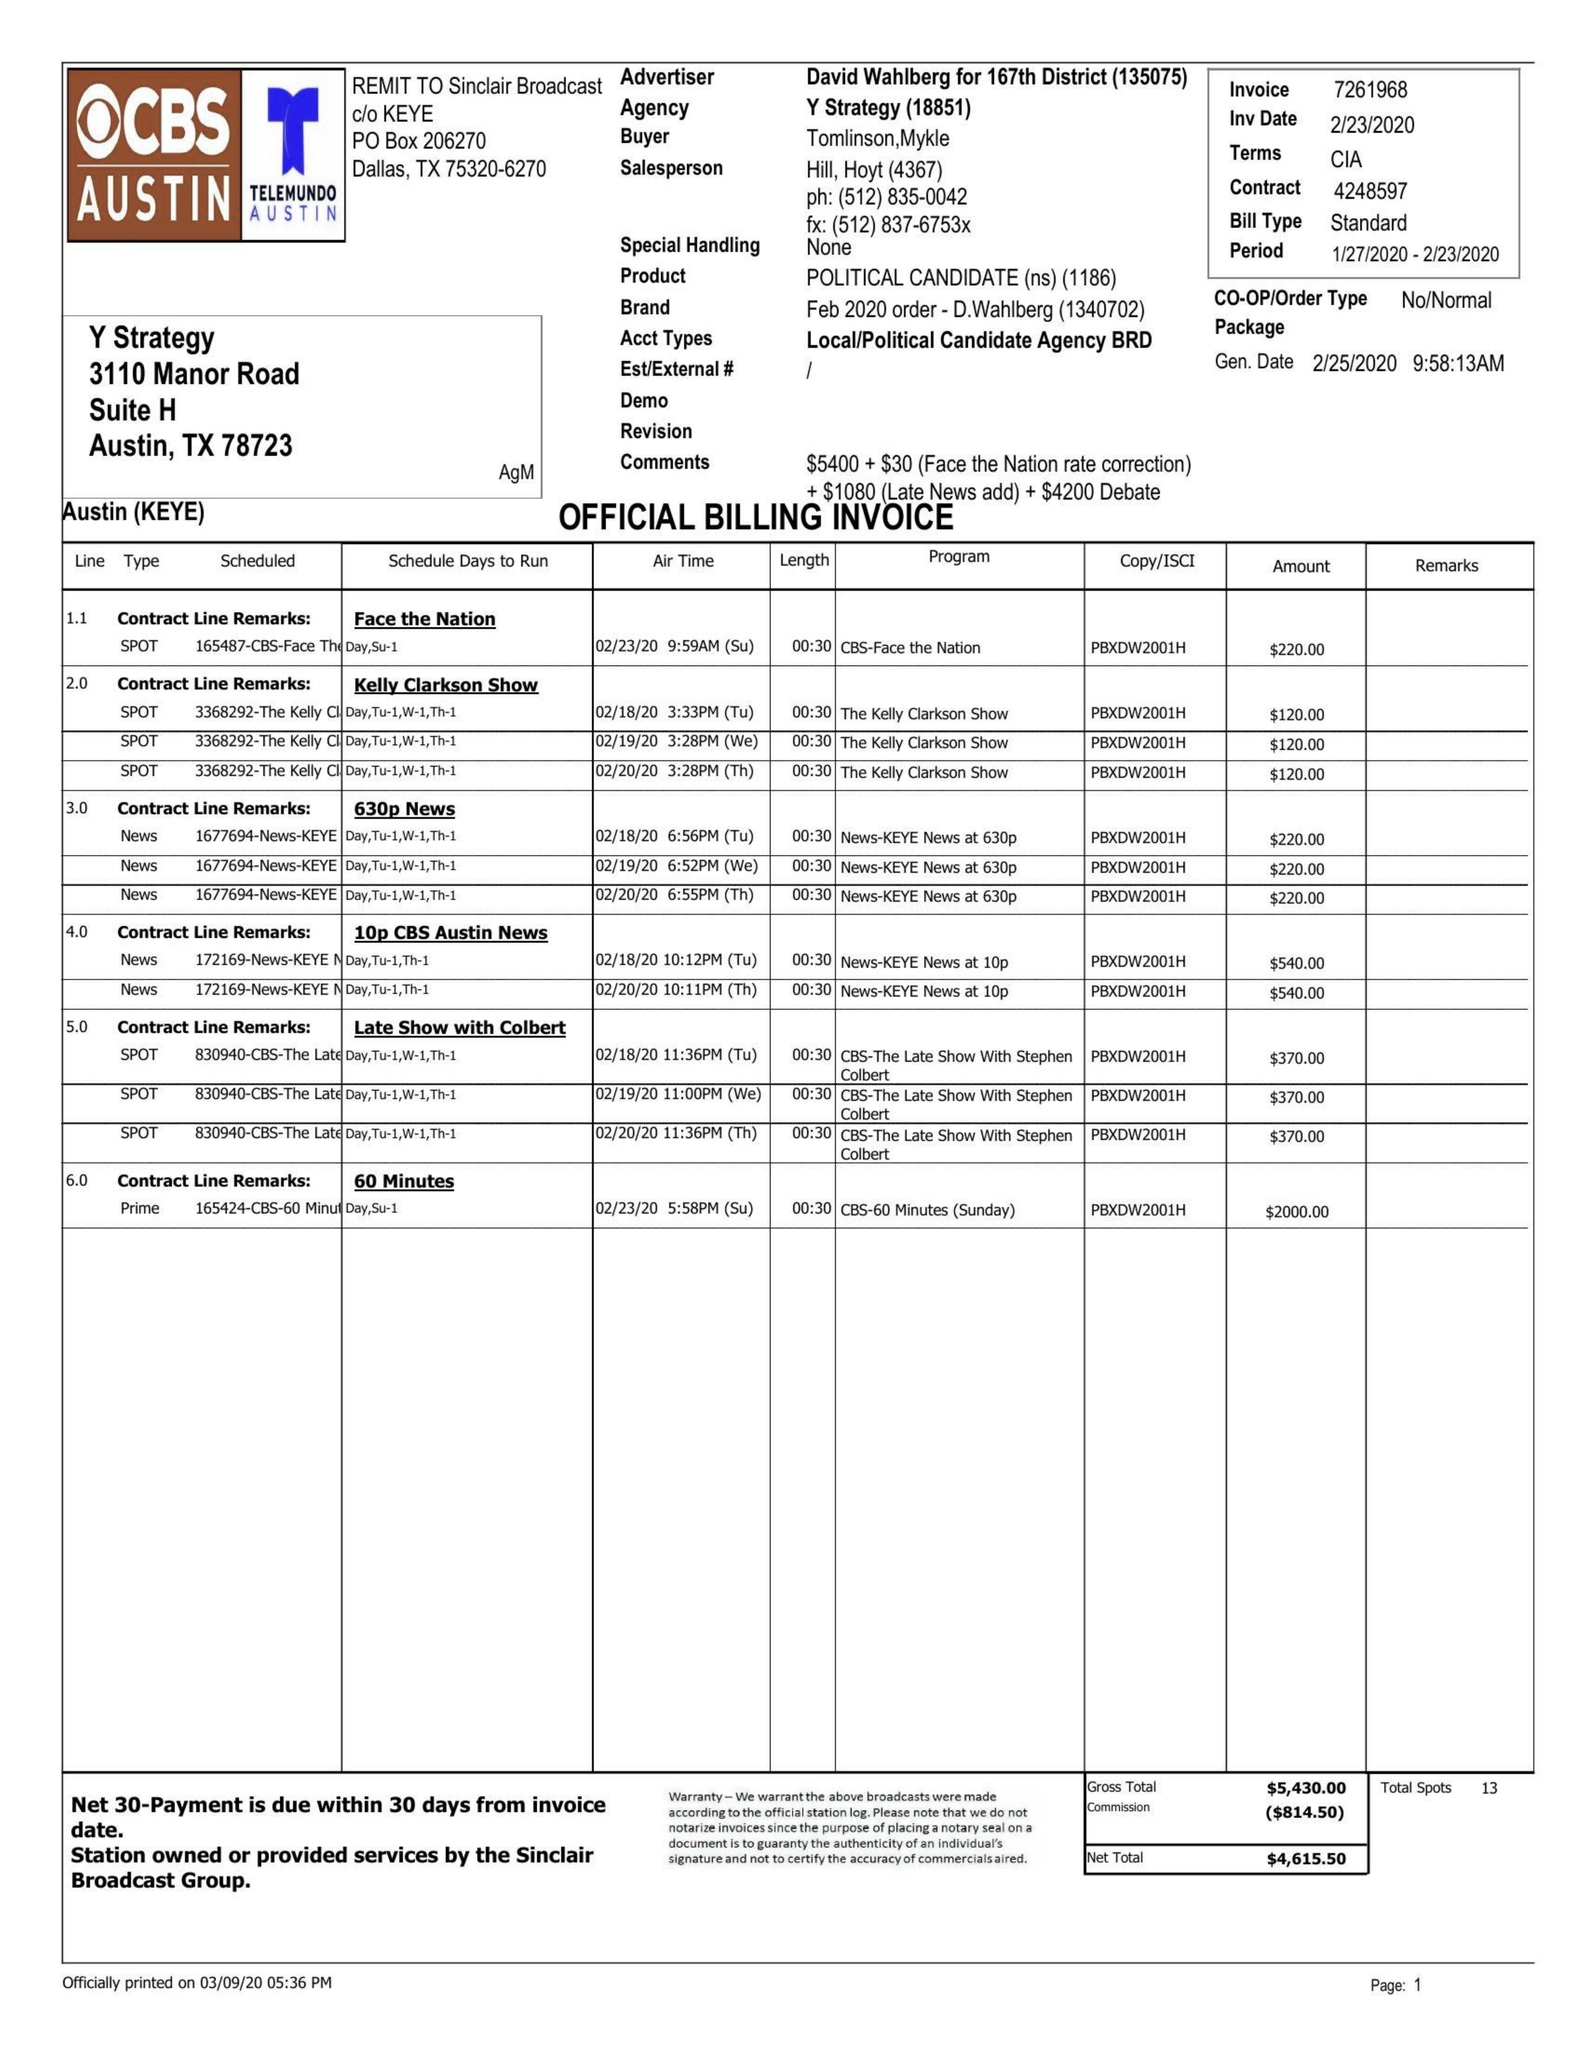What is the value for the flight_from?
Answer the question using a single word or phrase. 01/27/20 